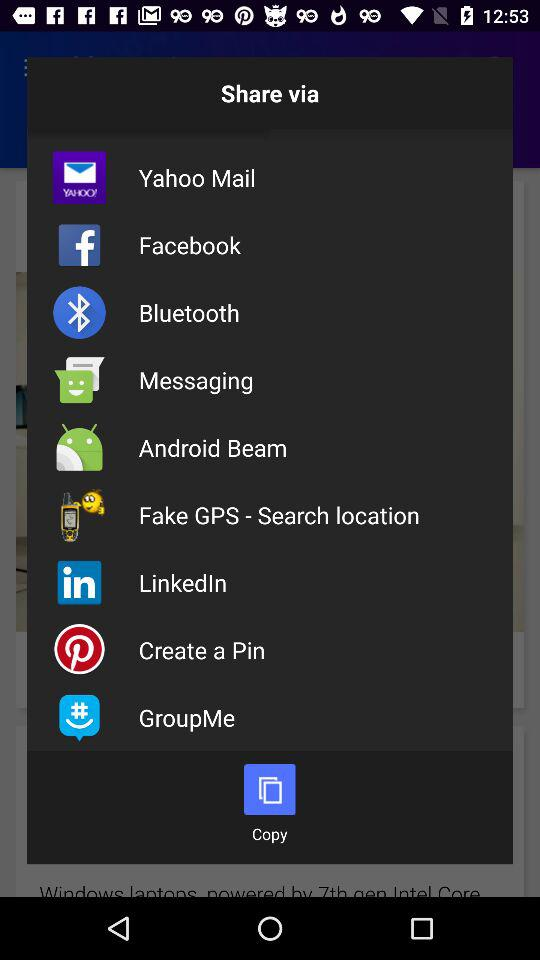What are the different options we can share? The different options are: " Yahoo Mail", " Facebook", "Bluetooth", "Messaging", "Android Beam", "Fake GPS - Search location"," LinkedIn", " Create a Pin", and "GroupMe". 